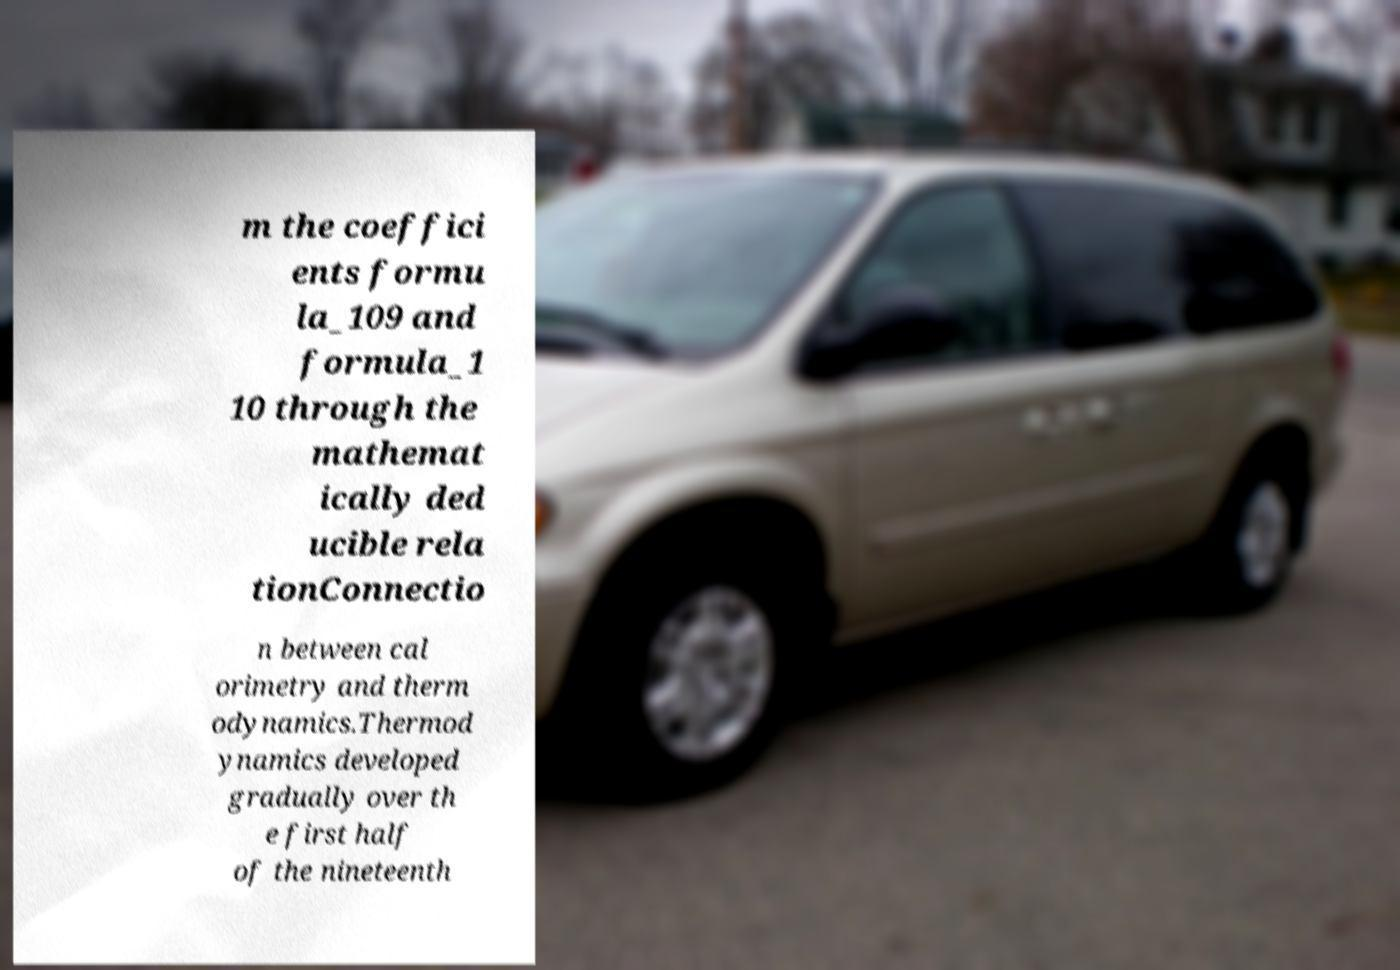Could you assist in decoding the text presented in this image and type it out clearly? m the coeffici ents formu la_109 and formula_1 10 through the mathemat ically ded ucible rela tionConnectio n between cal orimetry and therm odynamics.Thermod ynamics developed gradually over th e first half of the nineteenth 